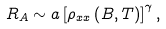<formula> <loc_0><loc_0><loc_500><loc_500>R _ { A } \sim a \left [ \rho _ { x x } \left ( B , T \right ) \right ] ^ { \gamma } ,</formula> 